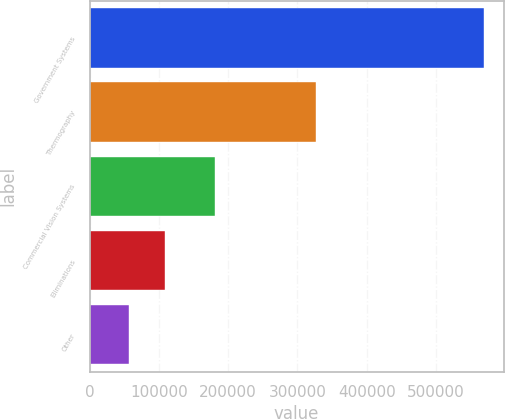<chart> <loc_0><loc_0><loc_500><loc_500><bar_chart><fcel>Government Systems<fcel>Thermography<fcel>Commercial Vision Systems<fcel>Eliminations<fcel>Other<nl><fcel>569028<fcel>327324<fcel>180622<fcel>108451<fcel>57276<nl></chart> 